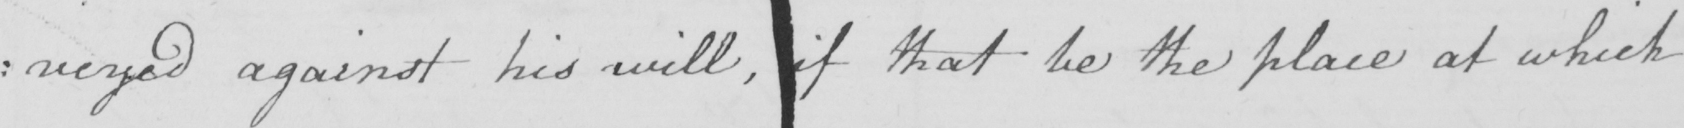Please provide the text content of this handwritten line. : nveyed against his will , if that be the place at which 